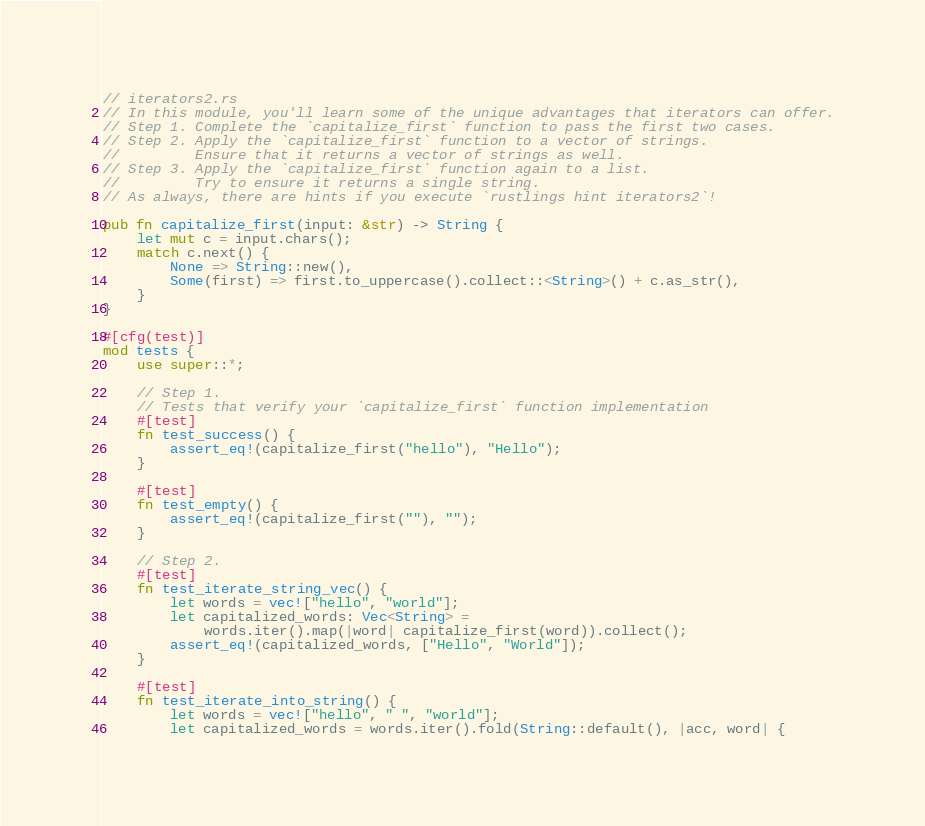<code> <loc_0><loc_0><loc_500><loc_500><_Rust_>// iterators2.rs
// In this module, you'll learn some of the unique advantages that iterators can offer.
// Step 1. Complete the `capitalize_first` function to pass the first two cases.
// Step 2. Apply the `capitalize_first` function to a vector of strings.
//         Ensure that it returns a vector of strings as well.
// Step 3. Apply the `capitalize_first` function again to a list.
//         Try to ensure it returns a single string.
// As always, there are hints if you execute `rustlings hint iterators2`!

pub fn capitalize_first(input: &str) -> String {
    let mut c = input.chars();
    match c.next() {
        None => String::new(),
        Some(first) => first.to_uppercase().collect::<String>() + c.as_str(),
    }
}

#[cfg(test)]
mod tests {
    use super::*;

    // Step 1.
    // Tests that verify your `capitalize_first` function implementation
    #[test]
    fn test_success() {
        assert_eq!(capitalize_first("hello"), "Hello");
    }

    #[test]
    fn test_empty() {
        assert_eq!(capitalize_first(""), "");
    }

    // Step 2.
    #[test]
    fn test_iterate_string_vec() {
        let words = vec!["hello", "world"];
        let capitalized_words: Vec<String> =
            words.iter().map(|word| capitalize_first(word)).collect();
        assert_eq!(capitalized_words, ["Hello", "World"]);
    }

    #[test]
    fn test_iterate_into_string() {
        let words = vec!["hello", " ", "world"];
        let capitalized_words = words.iter().fold(String::default(), |acc, word| {</code> 